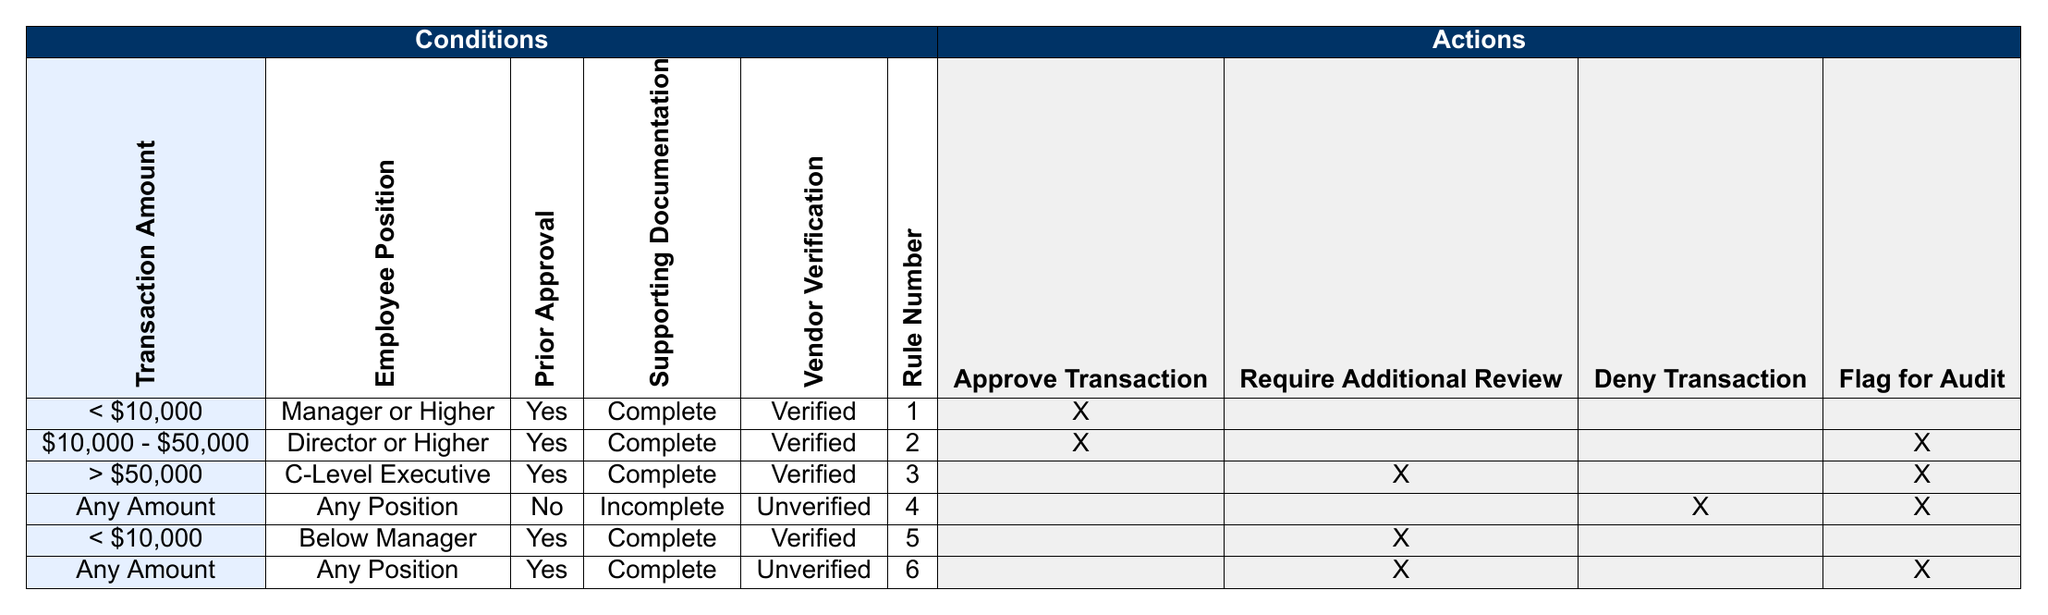What is the action taken for a transaction amount less than $10,000 approved by a Manager or Higher? In the first rule of the table, where the Transaction Amount is less than $10,000, Employee Position is Manager or Higher, and Prior Approval is Yes with Supporting Documentation Complete and Vendor Verification Verified, the action taken is to Approve the Transaction.
Answer: Approve Transaction What happens to a transaction between $10,000 and $50,000 approved by a Director or Higher? Referring to the second rule, for a transaction amount between $10,000 and $50,000, if the Employee Position is Director or Higher and prior approval is granted with complete supporting documentation and verified vendor, the transaction is approved, but it is also flagged for audit.
Answer: Approve Transaction and Flag for Audit Is additional review required for transactions over $50,000 approved by a C-Level Executive? According to the third rule, if a transaction exceeds $50,000 and is approved by a C-Level Executive with complete supporting documentation and verified vendor, it requires additional review.
Answer: Yes How many rules require denial of transactions? There are two rules in the table that specify denying transactions. One rule (Rule 4) says to deny any transaction with incomplete supporting documentation and unverified vendors regardless of amount. Another rule (Rule 6) states transactions with any amount, prior approval, complete documentation, but unverified vendors should be denied.
Answer: 2 What are the criteria for denying a transaction? To deny a transaction, the criteria must include having any amount, insufficient supporting documentation (incomplete), and unverified vendor verification, as stated in Rule 4. Additionally, Rule 6 specifies that any amount of transaction with prior approval and complete documentation but unverified vendors must be denied.
Answer: Incomplete documentation and unverified vendor verification Are there any situations where a transaction can be approved without additional review? Yes, transactions less than $10,000 approved by a Manager or Higher with complete documentation can be approved without requiring additional review, as indicated in Rule 1.
Answer: Yes What is the maximum transaction amount that can be approved directly without being flagged for audit? The maximum transaction amount that can be directly approved without being flagged for audit is less than $10,000, when approved by a Manager or Higher under the first rule. Transactions of $10,000 or more with prior approval from a Director or Higher require an audit flag.
Answer: Less than $10,000 If an employee below Manager status attempts to approve a transaction below $10,000, what happens? Referring to Rule 5, if an employee below Manager status attempts to approve a transaction below $10,000, it will require additional review instead of being automatically approved.
Answer: Require Additional Review 